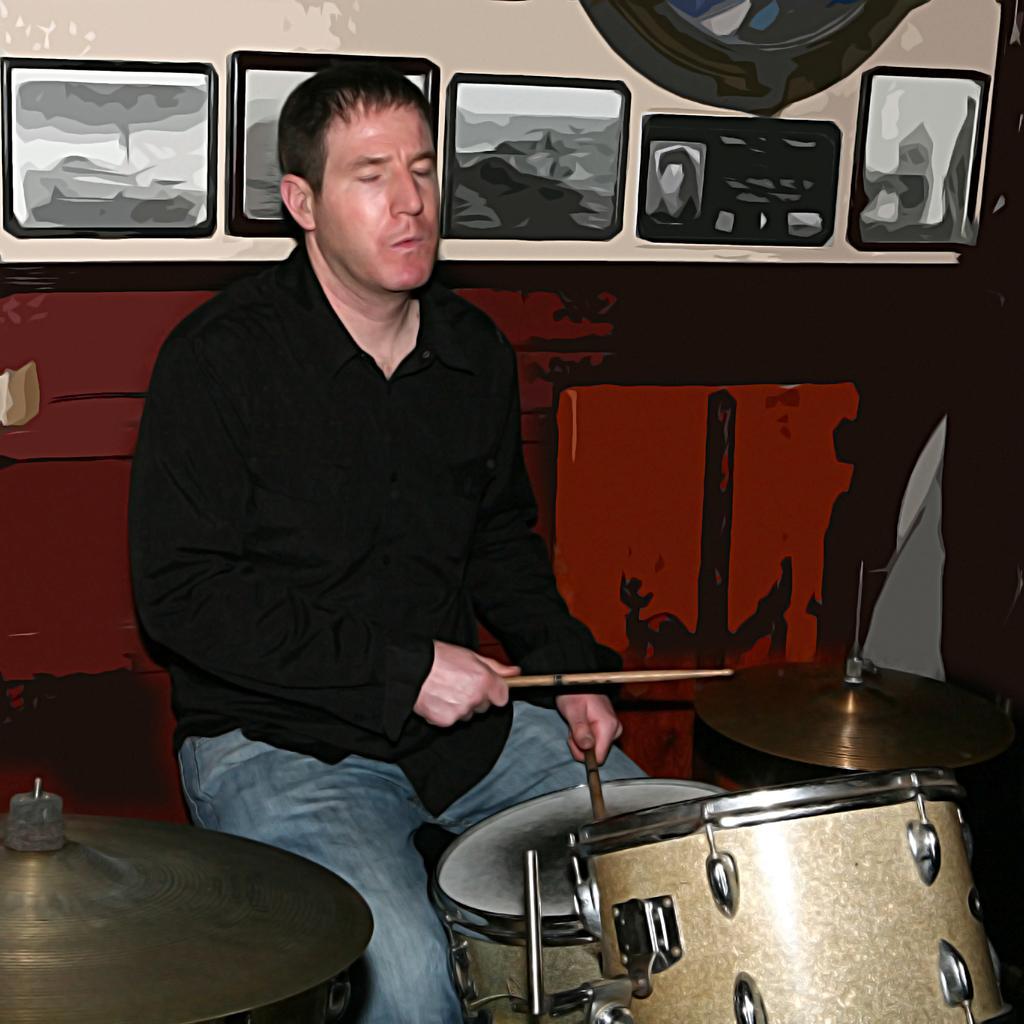In one or two sentences, can you explain what this image depicts? Here I can see a man wearing black color shirt, jeans, sitting and playing the drums. At the back of him there is a wall to which few frames are attached. 